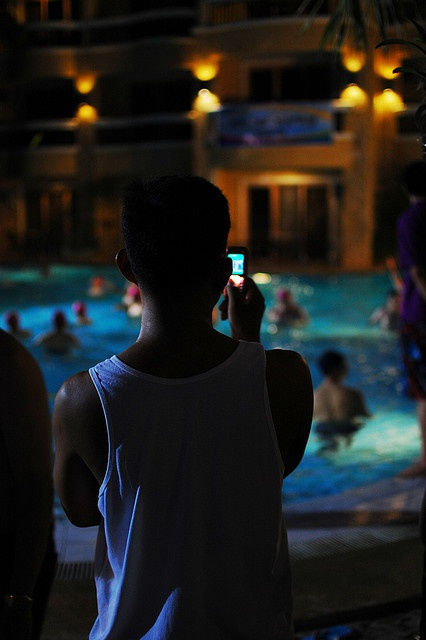Describe the objects in this image and their specific colors. I can see people in black, navy, blue, and gray tones, people in black and darkblue tones, people in black, gray, navy, and maroon tones, people in black, gray, and maroon tones, and people in black, gray, and teal tones in this image. 